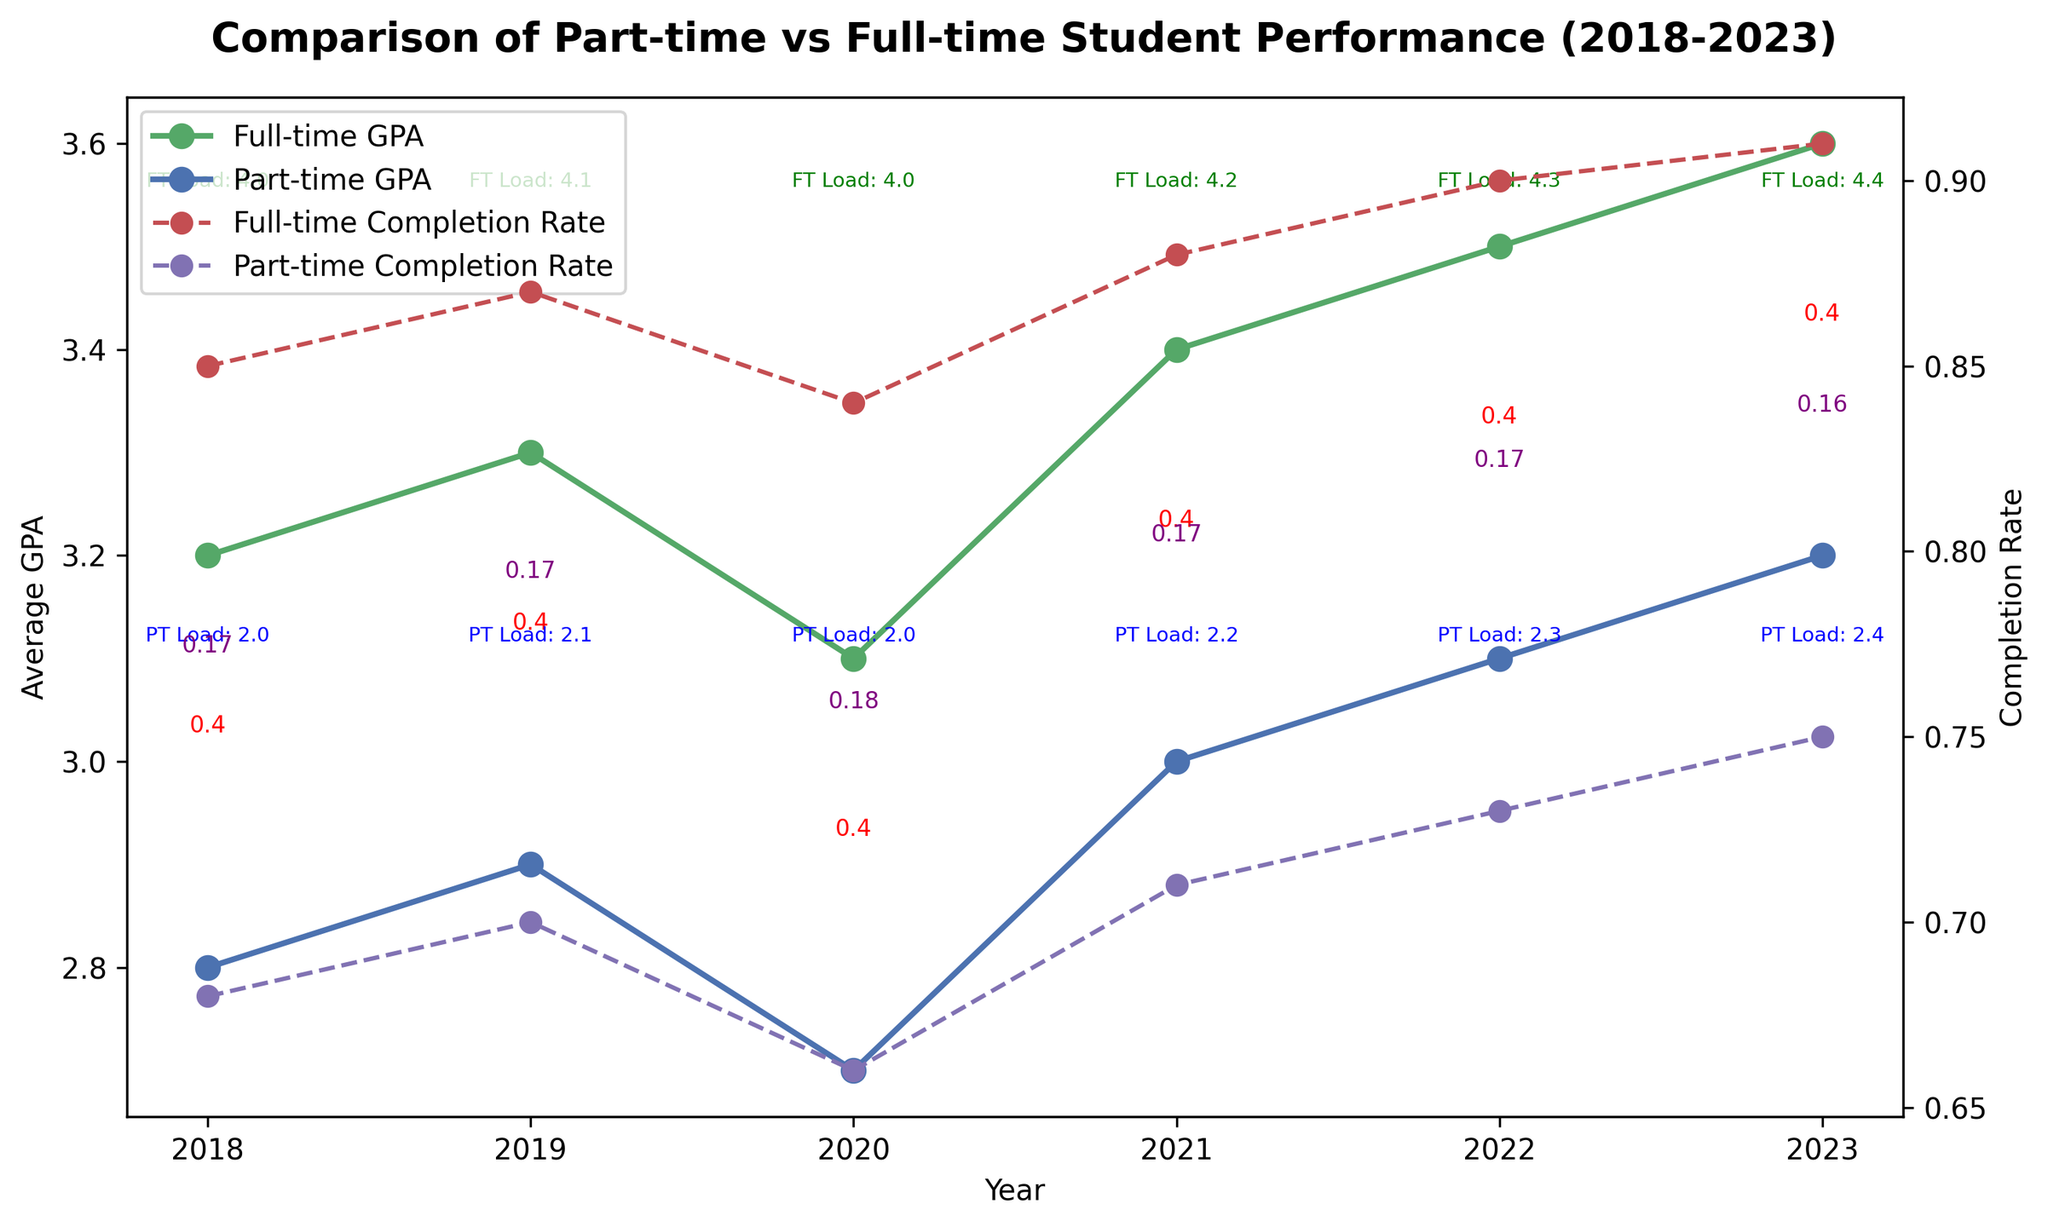How much did the GPA difference between Full-time and Part-time students change from 2018 to 2023? In 2018, the GPA difference was calculated as 3.2 - 2.8 = 0.4. In 2023, the GPA difference was calculated as 3.6 - 3.2 = 0.4. So, the change in GPA difference from 2018 to 2023 is 0.4 - 0.4 = 0.0
Answer: 0.0 Which year had the smallest difference in completion rates between Full-time and Part-time students? For each year, the difference in completion rates is as follows: 2018: 0.85 - 0.68 = 0.17; 2019: 0.87 - 0.70 = 0.17; 2020: 0.84 - 0.66 = 0.18; 2021: 0.88 - 0.71 = 0.17; 2022: 0.90 - 0.73 = 0.17; 2023: 0.91 - 0.75 = 0.16. Therefore, 2023 had the smallest difference of 0.16
Answer: 2023 What was the average course load difference between Full-time and Part-time students in 2021? In 2021, the Full-time students had an average course load of 4.2, and Part-time students had 2.2. The difference is calculated as 4.2 - 2.2 = 2.0
Answer: 2.0 Which student type showed a continuous increase in GPA from 2018 to 2023? Observing the trends from 2018 to 2023, Full-time students' GPA continuously increased each year from 3.2 to 3.6
Answer: Full-time In which year did the Part-time students have the lowest average course load, and what was the value? By analyzing the chart, Part-time students had the lowest average course load in 2018, with a value of 2.0
Answer: 2018, 2.0 How much higher was the completion rate for Full-time students compared to Part-time students in 2019? In 2019, the completion rates were 0.87 for Full-time students and 0.70 for Part-time students. The difference is 0.87 - 0.70 = 0.17
Answer: 0.17 Which student type had a higher GPA in 2020, and by how much? In 2020, Full-time students had a GPA of 3.1, while Part-time students had a GPA of 2.7. The difference is 3.1 - 2.7 = 0.4
Answer: Full-time by 0.4 Between 2021 and 2022, did the completion rate for Full-time students increase or decrease, and by how much? In 2021, the completion rate for Full-time students was 0.88, and in 2022 it was 0.90. The change is calculated as 0.90 - 0.88 = 0.02, indicating an increase
Answer: Increase by 0.02 Compare the trends in completion rates for both student types from 2018 to 2023. Which student type showed a steady increase? Analysis of the trends shows that Full-time students' completion rates steadily increased from 2018 (0.85) to 2023 (0.91), whereas Part-time students also showed an increase but not as steady as Full-time students
Answer: Full-time In which year did the Part-time students first achieve an Average GPA of 3.0 or higher? By examining the chart, Part-time students first had an Average GPA of 3.0 or higher in 2021, where the GPA was 3.0
Answer: 2021 